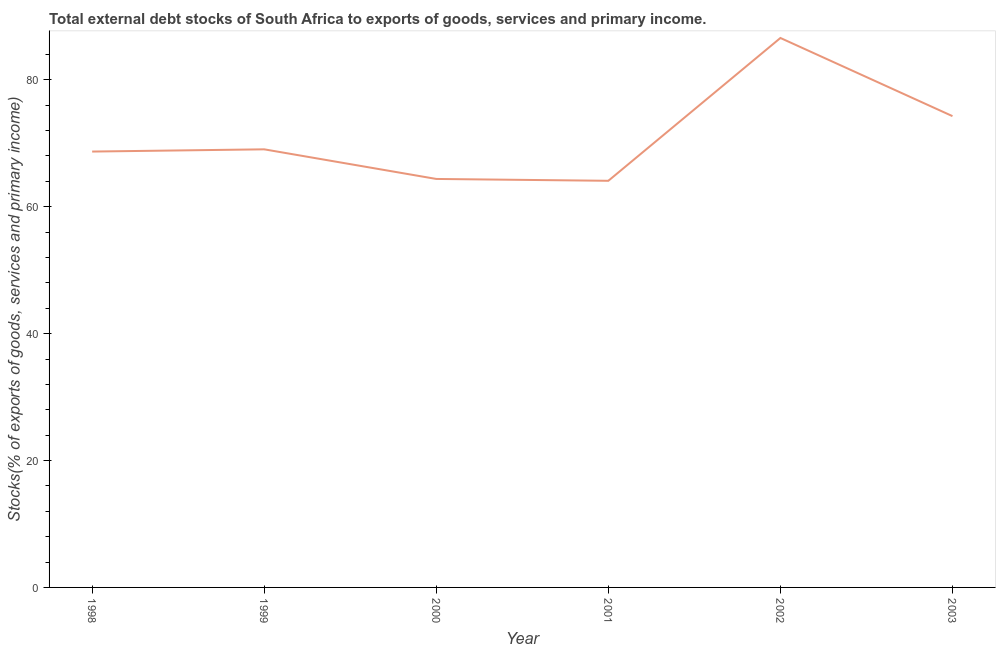What is the external debt stocks in 2000?
Give a very brief answer. 64.38. Across all years, what is the maximum external debt stocks?
Keep it short and to the point. 86.6. Across all years, what is the minimum external debt stocks?
Your response must be concise. 64.09. In which year was the external debt stocks maximum?
Your answer should be compact. 2002. In which year was the external debt stocks minimum?
Give a very brief answer. 2001. What is the sum of the external debt stocks?
Keep it short and to the point. 427.11. What is the difference between the external debt stocks in 1998 and 2001?
Your answer should be very brief. 4.61. What is the average external debt stocks per year?
Provide a succinct answer. 71.18. What is the median external debt stocks?
Offer a terse response. 68.87. Do a majority of the years between 1998 and 2001 (inclusive) have external debt stocks greater than 28 %?
Ensure brevity in your answer.  Yes. What is the ratio of the external debt stocks in 1998 to that in 1999?
Offer a very short reply. 0.99. Is the external debt stocks in 1999 less than that in 2003?
Offer a very short reply. Yes. Is the difference between the external debt stocks in 1999 and 2001 greater than the difference between any two years?
Your answer should be compact. No. What is the difference between the highest and the second highest external debt stocks?
Your response must be concise. 12.32. Is the sum of the external debt stocks in 1999 and 2002 greater than the maximum external debt stocks across all years?
Make the answer very short. Yes. What is the difference between the highest and the lowest external debt stocks?
Your answer should be compact. 22.51. In how many years, is the external debt stocks greater than the average external debt stocks taken over all years?
Give a very brief answer. 2. How many lines are there?
Make the answer very short. 1. What is the difference between two consecutive major ticks on the Y-axis?
Offer a very short reply. 20. Does the graph contain any zero values?
Your answer should be compact. No. Does the graph contain grids?
Make the answer very short. No. What is the title of the graph?
Your response must be concise. Total external debt stocks of South Africa to exports of goods, services and primary income. What is the label or title of the X-axis?
Offer a very short reply. Year. What is the label or title of the Y-axis?
Your answer should be very brief. Stocks(% of exports of goods, services and primary income). What is the Stocks(% of exports of goods, services and primary income) of 1998?
Provide a short and direct response. 68.7. What is the Stocks(% of exports of goods, services and primary income) in 1999?
Provide a succinct answer. 69.05. What is the Stocks(% of exports of goods, services and primary income) in 2000?
Your answer should be compact. 64.38. What is the Stocks(% of exports of goods, services and primary income) of 2001?
Give a very brief answer. 64.09. What is the Stocks(% of exports of goods, services and primary income) in 2002?
Your answer should be compact. 86.6. What is the Stocks(% of exports of goods, services and primary income) in 2003?
Provide a succinct answer. 74.28. What is the difference between the Stocks(% of exports of goods, services and primary income) in 1998 and 1999?
Give a very brief answer. -0.35. What is the difference between the Stocks(% of exports of goods, services and primary income) in 1998 and 2000?
Provide a succinct answer. 4.32. What is the difference between the Stocks(% of exports of goods, services and primary income) in 1998 and 2001?
Give a very brief answer. 4.61. What is the difference between the Stocks(% of exports of goods, services and primary income) in 1998 and 2002?
Keep it short and to the point. -17.9. What is the difference between the Stocks(% of exports of goods, services and primary income) in 1998 and 2003?
Your answer should be compact. -5.58. What is the difference between the Stocks(% of exports of goods, services and primary income) in 1999 and 2000?
Keep it short and to the point. 4.67. What is the difference between the Stocks(% of exports of goods, services and primary income) in 1999 and 2001?
Ensure brevity in your answer.  4.96. What is the difference between the Stocks(% of exports of goods, services and primary income) in 1999 and 2002?
Offer a very short reply. -17.55. What is the difference between the Stocks(% of exports of goods, services and primary income) in 1999 and 2003?
Your response must be concise. -5.23. What is the difference between the Stocks(% of exports of goods, services and primary income) in 2000 and 2001?
Ensure brevity in your answer.  0.29. What is the difference between the Stocks(% of exports of goods, services and primary income) in 2000 and 2002?
Provide a succinct answer. -22.22. What is the difference between the Stocks(% of exports of goods, services and primary income) in 2000 and 2003?
Offer a terse response. -9.9. What is the difference between the Stocks(% of exports of goods, services and primary income) in 2001 and 2002?
Offer a very short reply. -22.51. What is the difference between the Stocks(% of exports of goods, services and primary income) in 2001 and 2003?
Your response must be concise. -10.19. What is the difference between the Stocks(% of exports of goods, services and primary income) in 2002 and 2003?
Provide a succinct answer. 12.32. What is the ratio of the Stocks(% of exports of goods, services and primary income) in 1998 to that in 1999?
Your response must be concise. 0.99. What is the ratio of the Stocks(% of exports of goods, services and primary income) in 1998 to that in 2000?
Your response must be concise. 1.07. What is the ratio of the Stocks(% of exports of goods, services and primary income) in 1998 to that in 2001?
Your answer should be compact. 1.07. What is the ratio of the Stocks(% of exports of goods, services and primary income) in 1998 to that in 2002?
Keep it short and to the point. 0.79. What is the ratio of the Stocks(% of exports of goods, services and primary income) in 1998 to that in 2003?
Ensure brevity in your answer.  0.93. What is the ratio of the Stocks(% of exports of goods, services and primary income) in 1999 to that in 2000?
Keep it short and to the point. 1.07. What is the ratio of the Stocks(% of exports of goods, services and primary income) in 1999 to that in 2001?
Provide a succinct answer. 1.08. What is the ratio of the Stocks(% of exports of goods, services and primary income) in 1999 to that in 2002?
Provide a short and direct response. 0.8. What is the ratio of the Stocks(% of exports of goods, services and primary income) in 1999 to that in 2003?
Your answer should be compact. 0.93. What is the ratio of the Stocks(% of exports of goods, services and primary income) in 2000 to that in 2002?
Keep it short and to the point. 0.74. What is the ratio of the Stocks(% of exports of goods, services and primary income) in 2000 to that in 2003?
Your answer should be compact. 0.87. What is the ratio of the Stocks(% of exports of goods, services and primary income) in 2001 to that in 2002?
Your answer should be compact. 0.74. What is the ratio of the Stocks(% of exports of goods, services and primary income) in 2001 to that in 2003?
Offer a very short reply. 0.86. What is the ratio of the Stocks(% of exports of goods, services and primary income) in 2002 to that in 2003?
Provide a short and direct response. 1.17. 